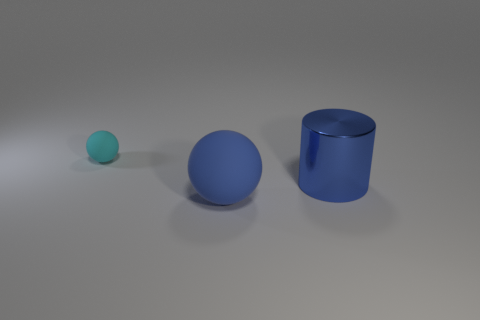Add 2 big yellow metal balls. How many objects exist? 5 Subtract all spheres. How many objects are left? 1 Subtract 0 brown balls. How many objects are left? 3 Subtract all cyan balls. Subtract all red cylinders. How many balls are left? 1 Subtract all tiny red matte objects. Subtract all big things. How many objects are left? 1 Add 3 blue balls. How many blue balls are left? 4 Add 1 large green metal objects. How many large green metal objects exist? 1 